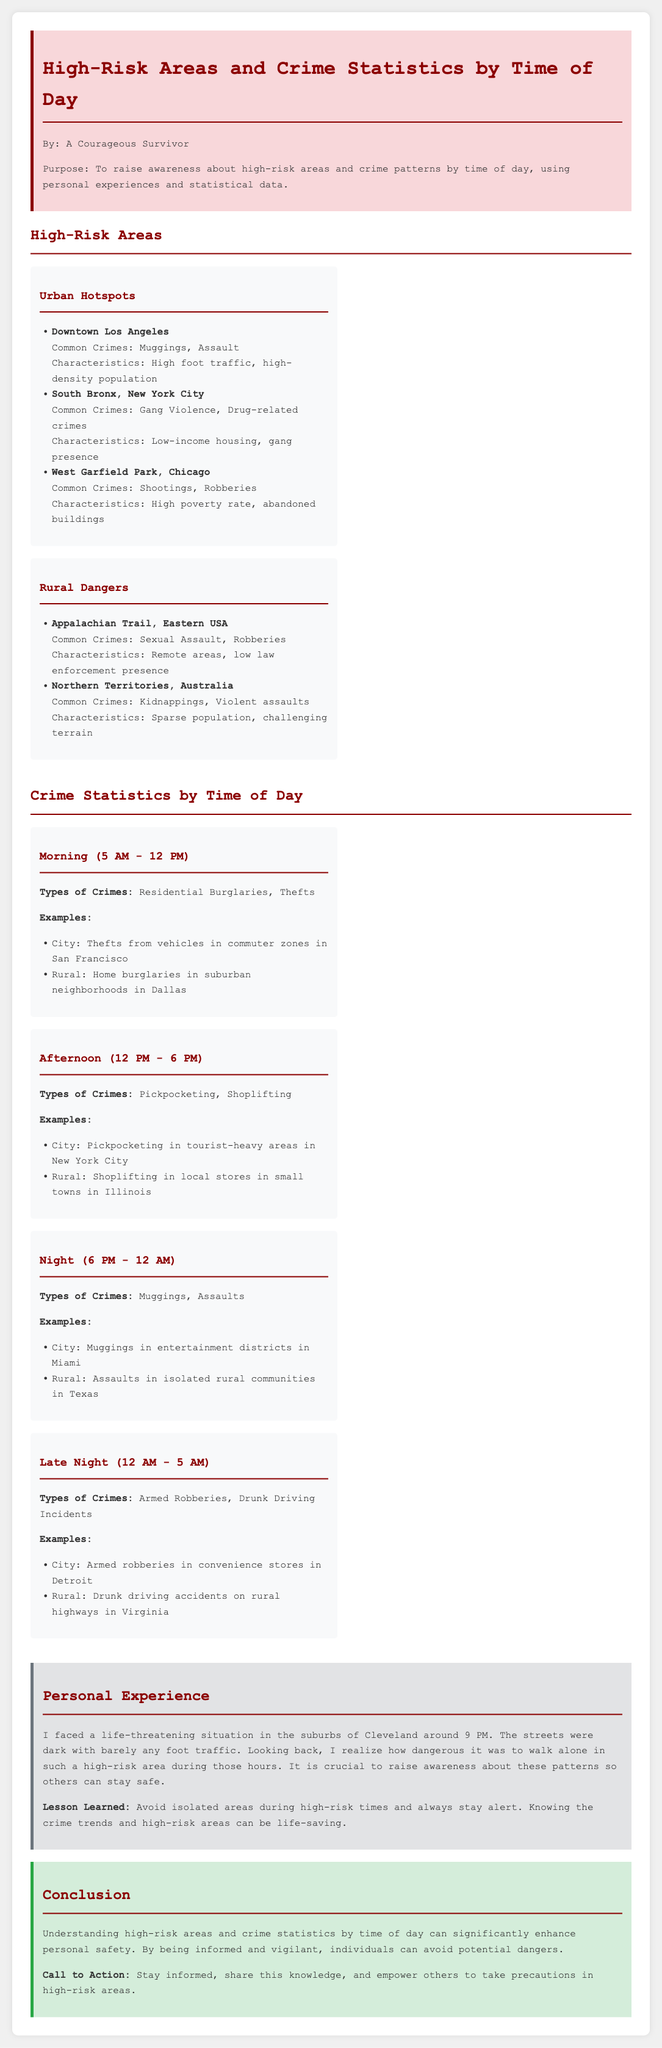What are some common crimes in Downtown Los Angeles? Downtown Los Angeles has common crimes, including muggings and assaults.
Answer: Muggings, Assault What is a characteristic of West Garfield Park in Chicago? West Garfield Park is characterized by a high poverty rate and abandoned buildings.
Answer: High poverty rate, abandoned buildings What types of crimes occur during the morning? The types of crimes during the morning are residential burglaries and thefts.
Answer: Residential Burglaries, Thefts What lesson did the author learn from their personal experience? The author learned to avoid isolated areas during high-risk times and always stay alert.
Answer: Avoid isolated areas during high-risk times What is a common crime in the Appalachian Trail area? A common crime in the Appalachian Trail area is sexual assault.
Answer: Sexual Assault Which crime type is most associated with the late night hours? Armed robberies and drunk driving incidents are common during the late night hours.
Answer: Armed Robberies, Drunk Driving Incidents During which time frame do pickpocketing incidents occur? Pickpocketing incidents occur during the afternoon from 12 PM to 6 PM.
Answer: Afternoon (12 PM - 6 PM) What was the author's original location of the life-threatening situation? The author's life-threatening situation occurred in the suburbs of Cleveland.
Answer: Suburbs of Cleveland What is the purpose of the report? The purpose of the report is to raise awareness about high-risk areas and crime patterns.
Answer: Raise awareness about high-risk areas and crime patterns 